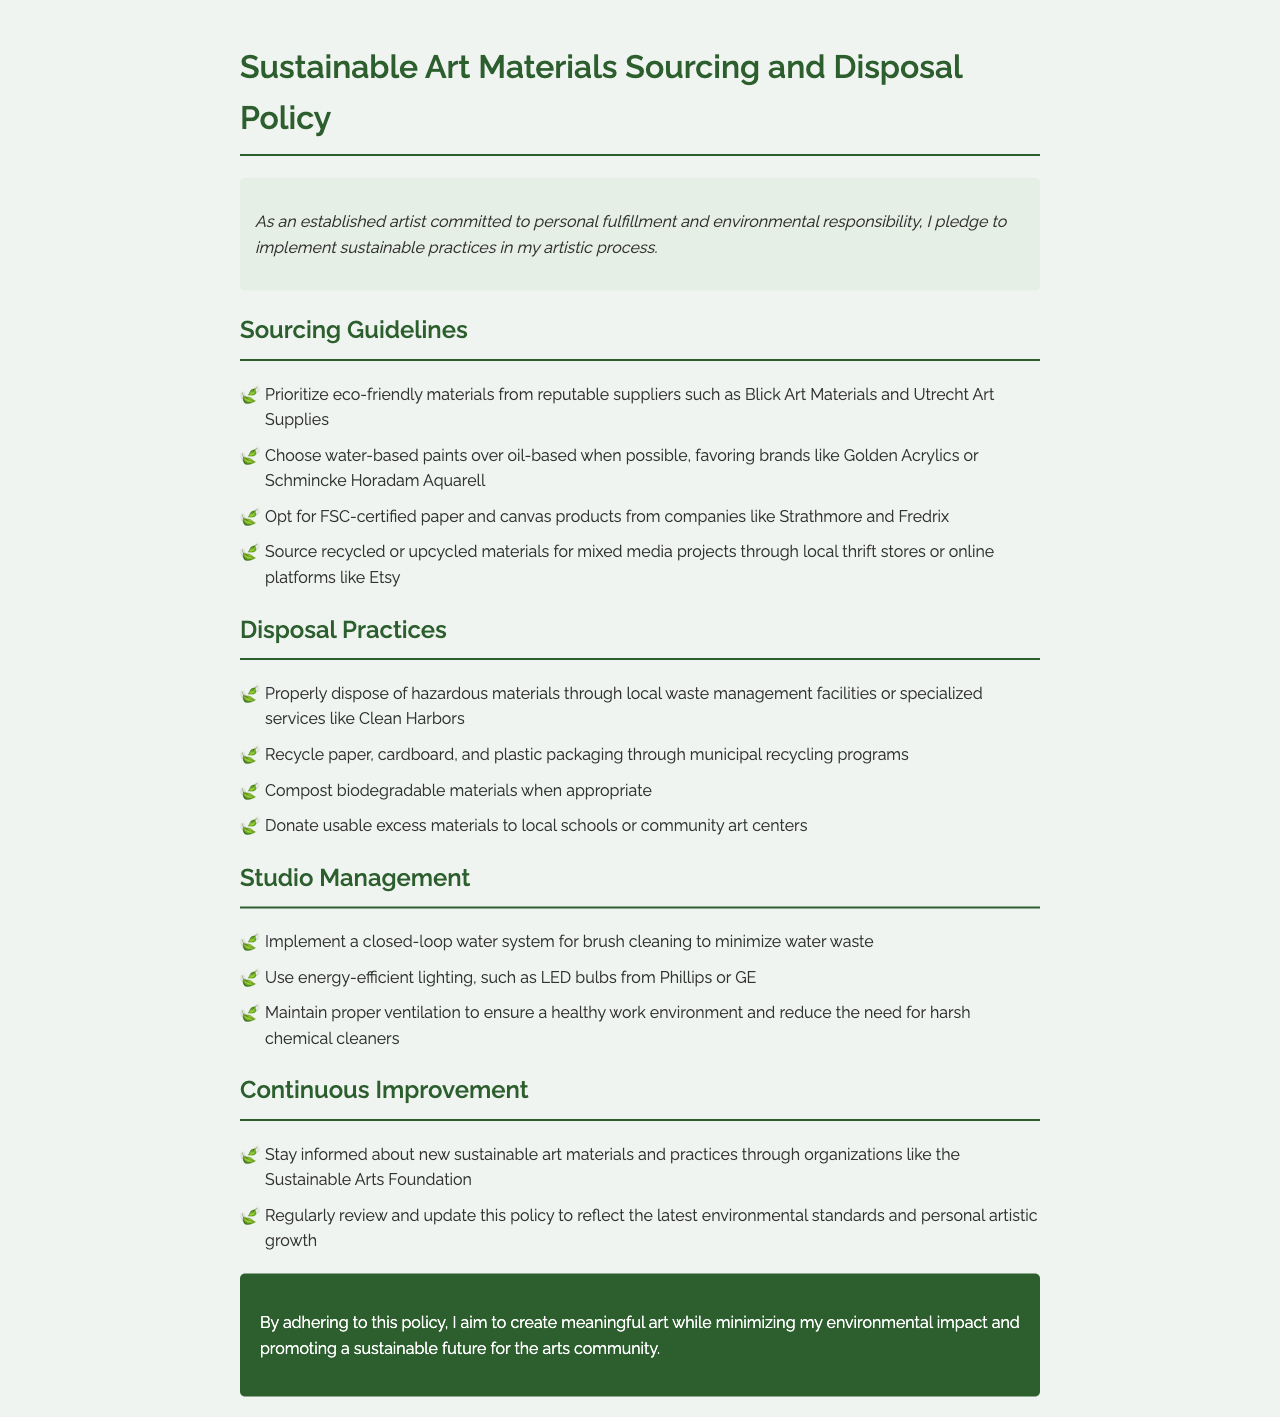what is the title of the policy document? The title of the document is the main heading at the top of the page, which states the purpose of the document.
Answer: Sustainable Art Materials Sourcing and Disposal Policy who is committed to the sustainable practices mentioned in the document? The artist statement reveals the individual who is dedicated to these practices.
Answer: established artist which type of paper products should be prioritized according to the sourcing guidelines? The guidelines specify a preference for certain environmentally friendly materials in the sourcing section.
Answer: FSC-certified what should be done with hazardous materials? The disposal practices outline the recommended action for hazardous materials to ensure safe disposal.
Answer: local waste management facilities name one type of lighting recommended for studio management. The studio management section provides a suggestion for energy-efficient lighting options.
Answer: LED bulbs how often should the policy be reviewed? The continuous improvement section indicates how frequently the document should be evaluated to stay updated.
Answer: regularly where can recycled materials be sourced for mixed media projects? The sourcing guidelines suggest places to find specific types of materials for projects.
Answer: local thrift stores what color is used for headings in the document? The style of headings is indicated by the color used in the visual design of the document.
Answer: #2c5e2e 